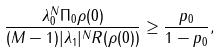<formula> <loc_0><loc_0><loc_500><loc_500>\frac { \lambda _ { 0 } ^ { N } \| \Pi _ { 0 } \rho ( 0 ) \| } { ( M - 1 ) | \lambda _ { 1 } | ^ { N } R ( \rho ( 0 ) ) } \geq \frac { p _ { 0 } } { 1 - p _ { 0 } } ,</formula> 